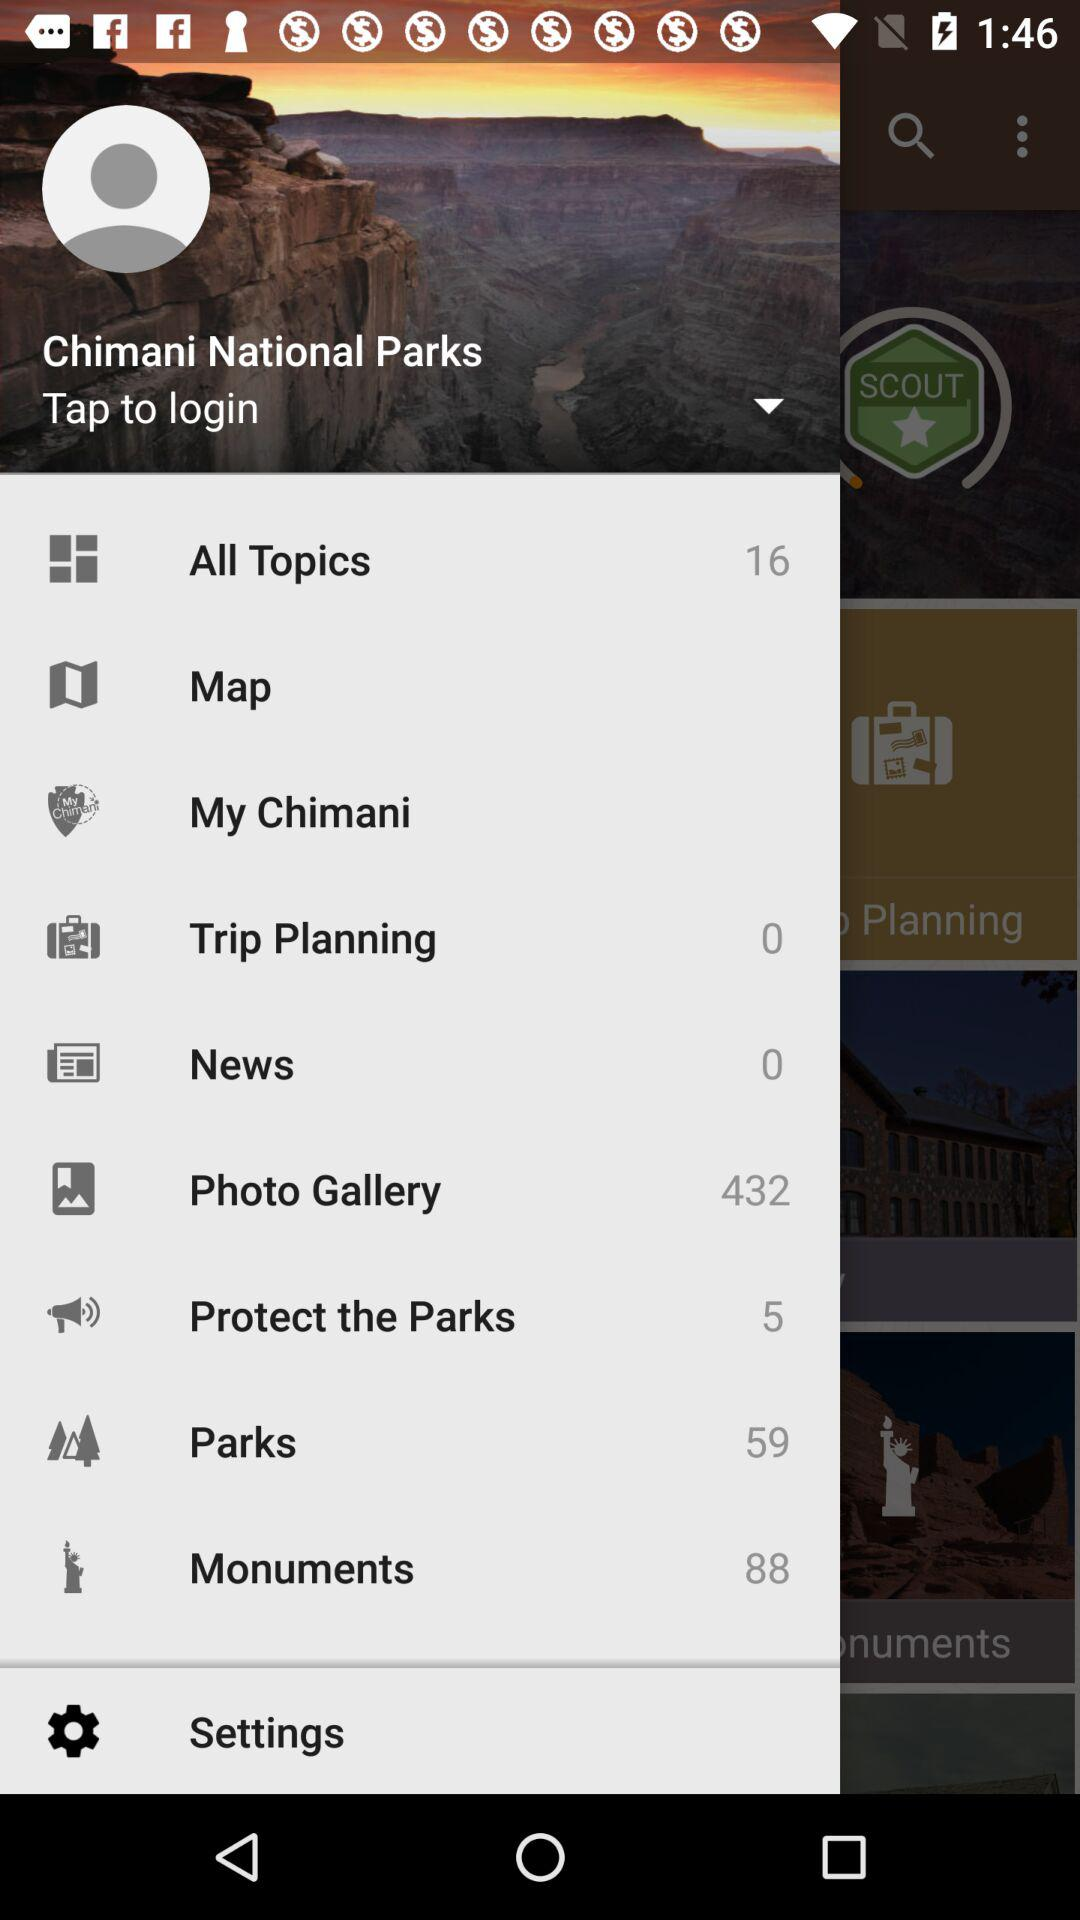What is the number of parks? The number of parks is 59. 